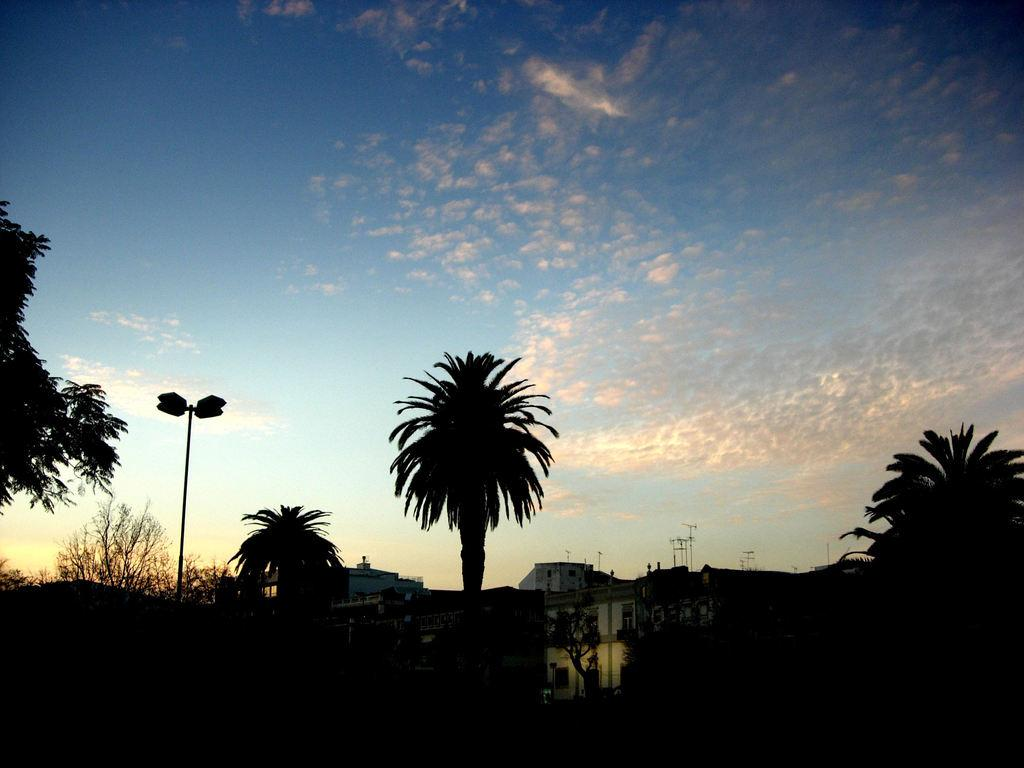What is located in the center of the image? There are buildings, a wall, poles, trees, and plants in the center of the image. Can you describe the background of the image? The sky is visible in the background of the image, and there are clouds present. What type of vegetation can be seen in the center of the image? There are trees and plants in the center of the image. Can you see the face of the person walking in the town in the image? There is no person walking in the town in the image, as it only features buildings, a wall, poles, trees, plants, and the sky with clouds in the background. 